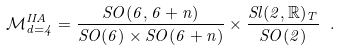Convert formula to latex. <formula><loc_0><loc_0><loc_500><loc_500>\mathcal { M } ^ { I I A } _ { d = 4 } = \frac { S O ( 6 , 6 + n ) } { S O ( 6 ) \times S O ( 6 + n ) } \times \frac { S l ( 2 , \mathbb { R } ) _ { T } } { S O ( 2 ) } \ .</formula> 